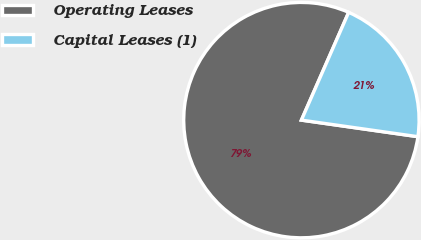Convert chart. <chart><loc_0><loc_0><loc_500><loc_500><pie_chart><fcel>Operating Leases<fcel>Capital Leases (1)<nl><fcel>79.33%<fcel>20.67%<nl></chart> 